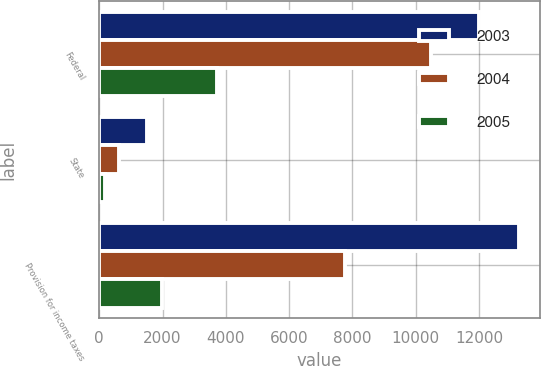<chart> <loc_0><loc_0><loc_500><loc_500><stacked_bar_chart><ecel><fcel>Federal<fcel>State<fcel>Provision for income taxes<nl><fcel>2003<fcel>12009<fcel>1509<fcel>13255<nl><fcel>2004<fcel>10485<fcel>630<fcel>7774<nl><fcel>2005<fcel>3724<fcel>185<fcel>1991<nl></chart> 